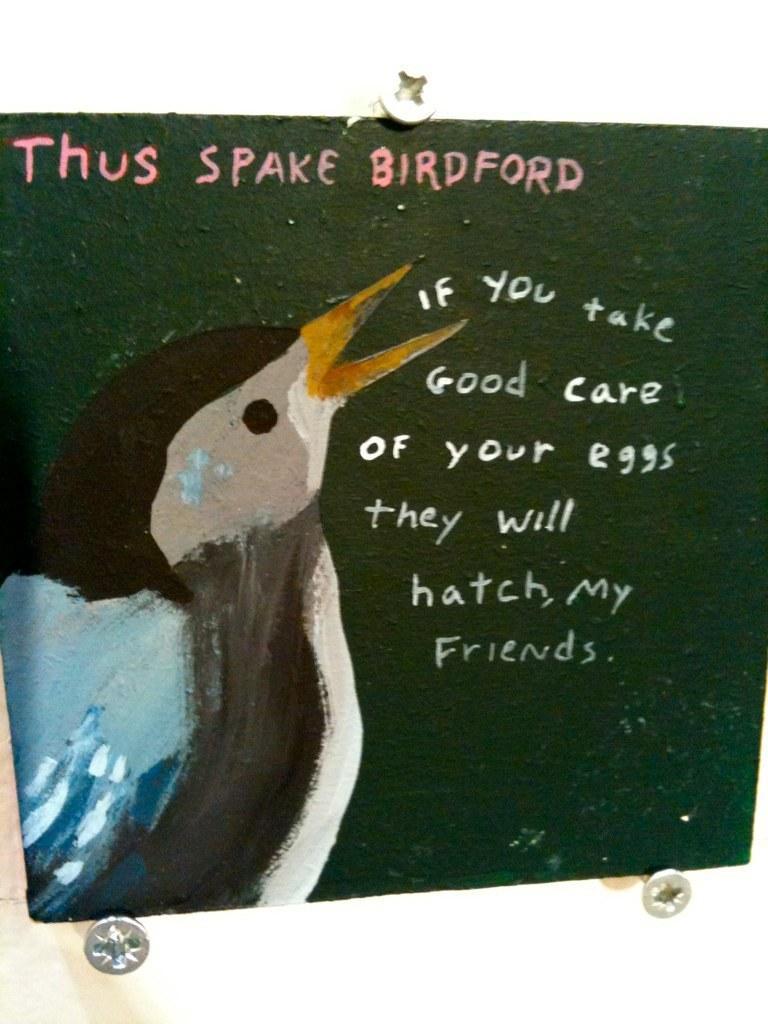In one or two sentences, can you explain what this image depicts? In this image I can see depiction of a bird and I can see something is written over here. I can also see green colour in background. 